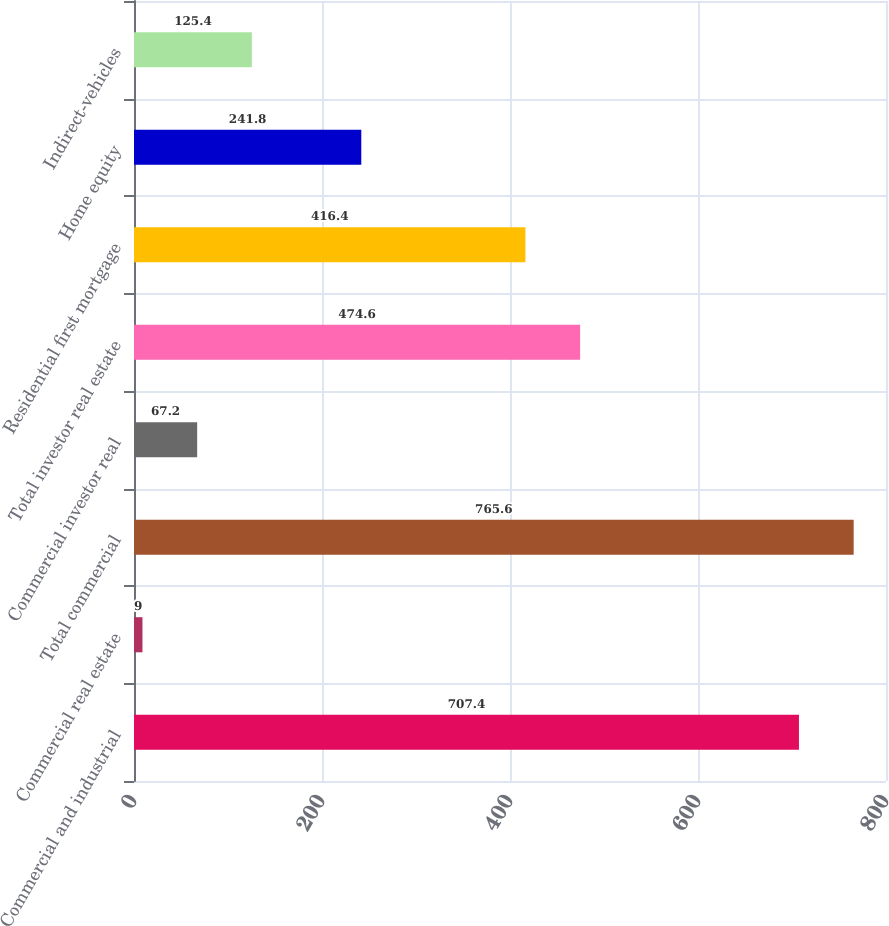<chart> <loc_0><loc_0><loc_500><loc_500><bar_chart><fcel>Commercial and industrial<fcel>Commercial real estate<fcel>Total commercial<fcel>Commercial investor real<fcel>Total investor real estate<fcel>Residential first mortgage<fcel>Home equity<fcel>Indirect-vehicles<nl><fcel>707.4<fcel>9<fcel>765.6<fcel>67.2<fcel>474.6<fcel>416.4<fcel>241.8<fcel>125.4<nl></chart> 